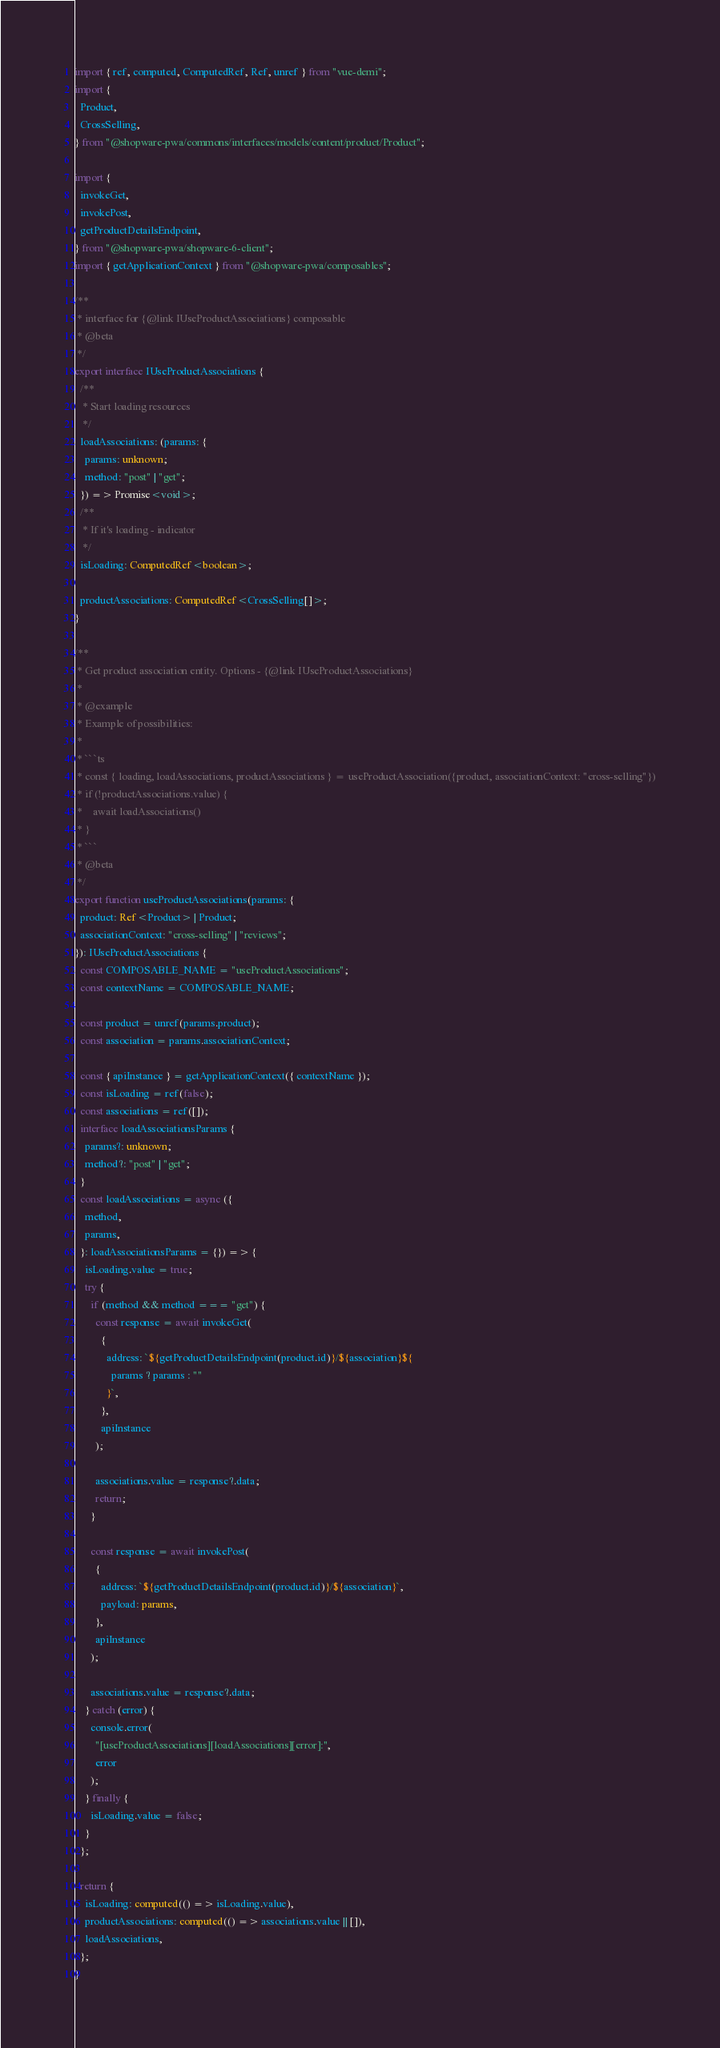<code> <loc_0><loc_0><loc_500><loc_500><_TypeScript_>import { ref, computed, ComputedRef, Ref, unref } from "vue-demi";
import {
  Product,
  CrossSelling,
} from "@shopware-pwa/commons/interfaces/models/content/product/Product";

import {
  invokeGet,
  invokePost,
  getProductDetailsEndpoint,
} from "@shopware-pwa/shopware-6-client";
import { getApplicationContext } from "@shopware-pwa/composables";

/**
 * interface for {@link IUseProductAssociations} composable
 * @beta
 */
export interface IUseProductAssociations {
  /**
   * Start loading resources
   */
  loadAssociations: (params: {
    params: unknown;
    method: "post" | "get";
  }) => Promise<void>;
  /**
   * If it's loading - indicator
   */
  isLoading: ComputedRef<boolean>;

  productAssociations: ComputedRef<CrossSelling[]>;
}

/**
 * Get product association entity. Options - {@link IUseProductAssociations}
 *
 * @example
 * Example of possibilities:
 *
 * ```ts
 * const { loading, loadAssociations, productAssociations } = useProductAssociation({product, associationContext: "cross-selling"})
 * if (!productAssociations.value) {
 *    await loadAssociations()
 * }
 * ```
 * @beta
 */
export function useProductAssociations(params: {
  product: Ref<Product> | Product;
  associationContext: "cross-selling" | "reviews";
}): IUseProductAssociations {
  const COMPOSABLE_NAME = "useProductAssociations";
  const contextName = COMPOSABLE_NAME;

  const product = unref(params.product);
  const association = params.associationContext;

  const { apiInstance } = getApplicationContext({ contextName });
  const isLoading = ref(false);
  const associations = ref([]);
  interface loadAssociationsParams {
    params?: unknown;
    method?: "post" | "get";
  }
  const loadAssociations = async ({
    method,
    params,
  }: loadAssociationsParams = {}) => {
    isLoading.value = true;
    try {
      if (method && method === "get") {
        const response = await invokeGet(
          {
            address: `${getProductDetailsEndpoint(product.id)}/${association}${
              params ? params : ""
            }`,
          },
          apiInstance
        );

        associations.value = response?.data;
        return;
      }

      const response = await invokePost(
        {
          address: `${getProductDetailsEndpoint(product.id)}/${association}`,
          payload: params,
        },
        apiInstance
      );

      associations.value = response?.data;
    } catch (error) {
      console.error(
        "[useProductAssociations][loadAssociations][error]:",
        error
      );
    } finally {
      isLoading.value = false;
    }
  };

  return {
    isLoading: computed(() => isLoading.value),
    productAssociations: computed(() => associations.value || []),
    loadAssociations,
  };
}
</code> 